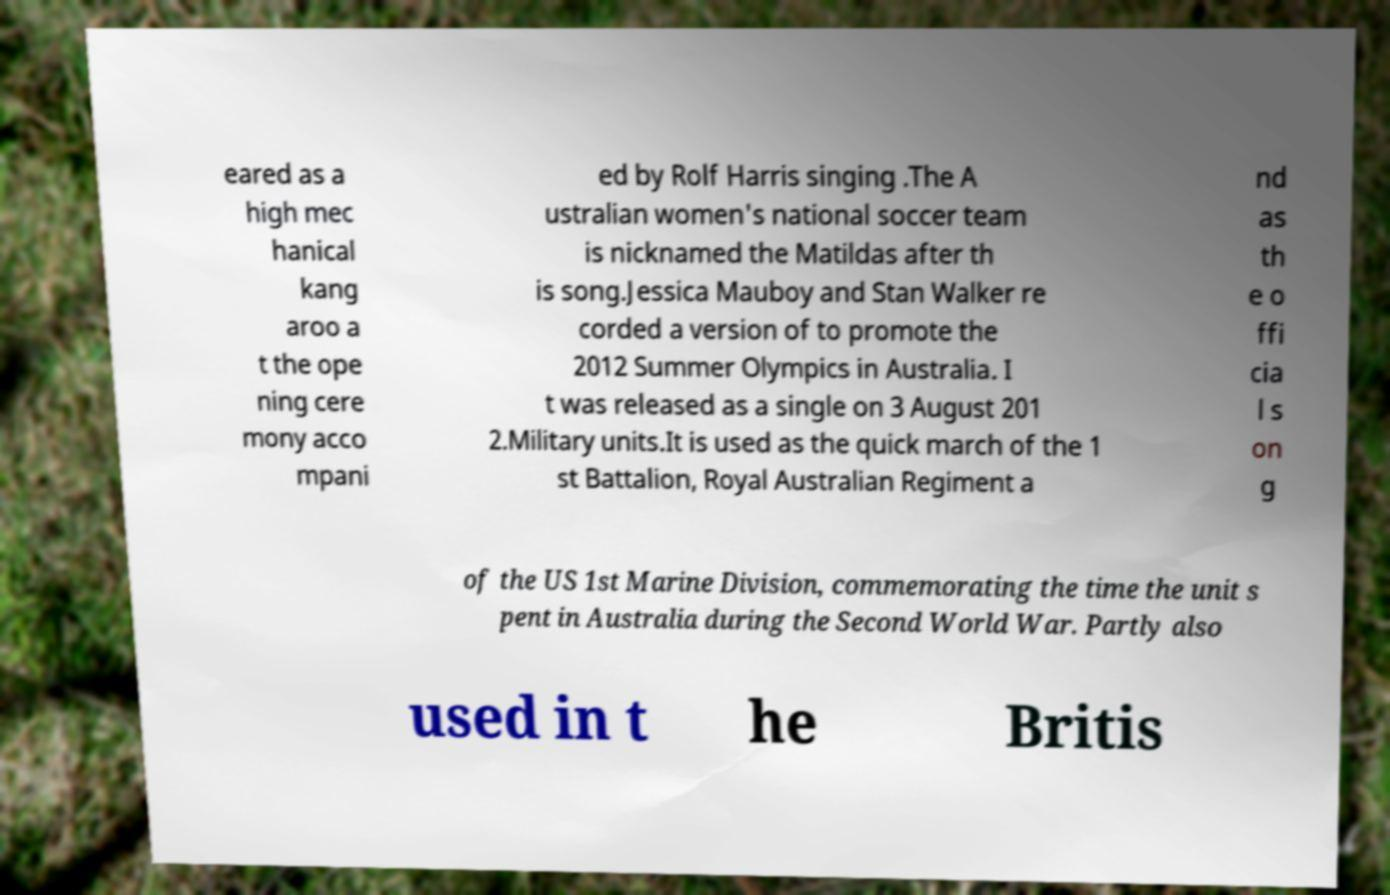Could you assist in decoding the text presented in this image and type it out clearly? eared as a high mec hanical kang aroo a t the ope ning cere mony acco mpani ed by Rolf Harris singing .The A ustralian women's national soccer team is nicknamed the Matildas after th is song.Jessica Mauboy and Stan Walker re corded a version of to promote the 2012 Summer Olympics in Australia. I t was released as a single on 3 August 201 2.Military units.It is used as the quick march of the 1 st Battalion, Royal Australian Regiment a nd as th e o ffi cia l s on g of the US 1st Marine Division, commemorating the time the unit s pent in Australia during the Second World War. Partly also used in t he Britis 